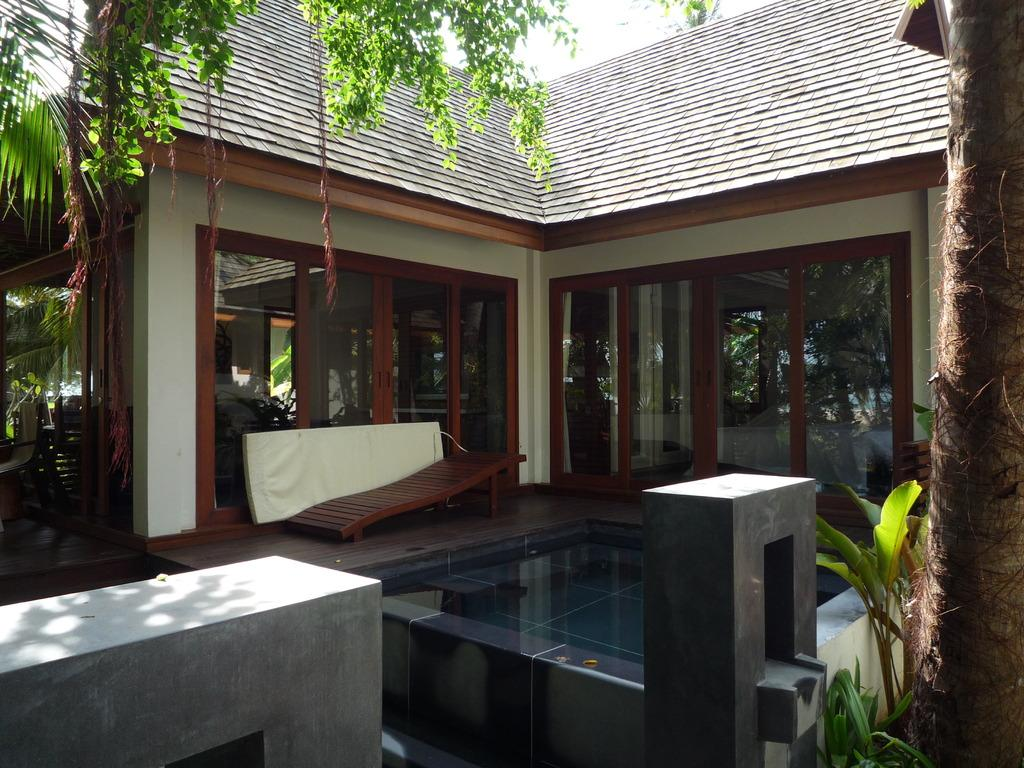What type of structure is present in the image? There is a house in the image. What is the color of the house? The house is brown in color. What objects can be seen in the image besides the house? There are glasses and many trees and plants visible in the image. What can be seen in the background of the image? The sky is visible in the background of the image. What type of attraction is present in the image? There is no attraction present in the image; it features a brown house, glasses, trees, plants, and the sky. What type of stone is used to build the house in the image? The facts provided do not mention the material used to build the house, so it cannot be determined from the image. 